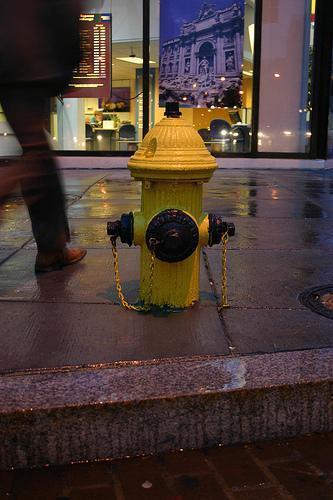How many hydrants are pictured?
Give a very brief answer. 1. How many black-painted pieces on the fire hydrant do not have a chain on them?
Give a very brief answer. 1. 